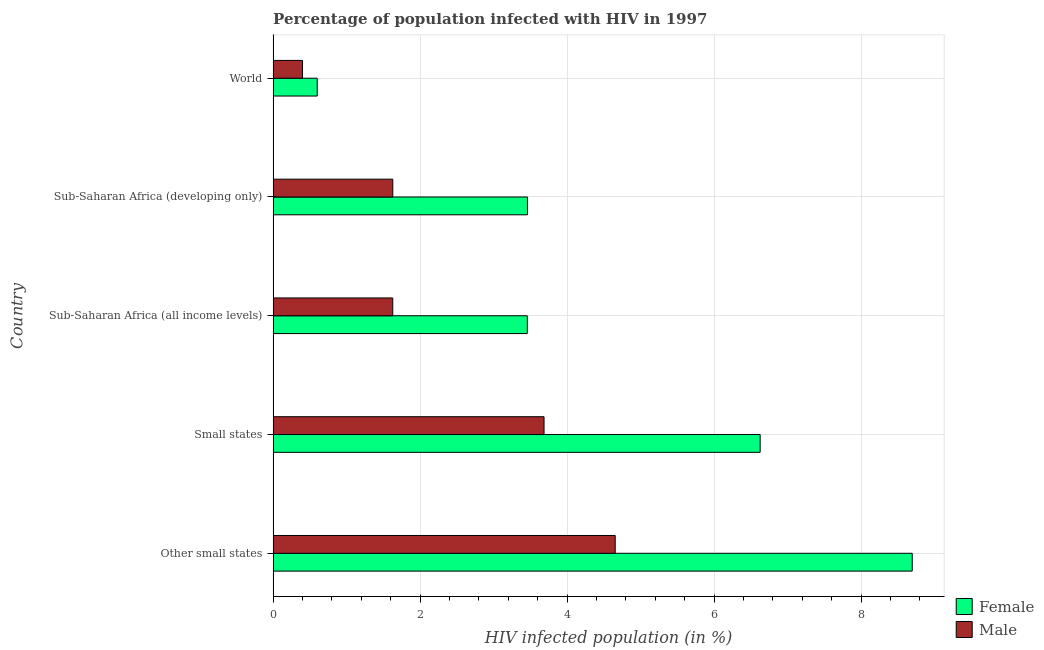How many groups of bars are there?
Your answer should be compact. 5. Are the number of bars on each tick of the Y-axis equal?
Your answer should be compact. Yes. How many bars are there on the 1st tick from the bottom?
Make the answer very short. 2. What is the label of the 5th group of bars from the top?
Offer a very short reply. Other small states. What is the percentage of females who are infected with hiv in Small states?
Offer a terse response. 6.63. Across all countries, what is the maximum percentage of males who are infected with hiv?
Your answer should be compact. 4.66. Across all countries, what is the minimum percentage of males who are infected with hiv?
Keep it short and to the point. 0.4. In which country was the percentage of females who are infected with hiv maximum?
Make the answer very short. Other small states. What is the total percentage of females who are infected with hiv in the graph?
Make the answer very short. 22.85. What is the difference between the percentage of males who are infected with hiv in Sub-Saharan Africa (all income levels) and that in Sub-Saharan Africa (developing only)?
Your answer should be compact. -0. What is the difference between the percentage of males who are infected with hiv in Sub-Saharan Africa (all income levels) and the percentage of females who are infected with hiv in Other small states?
Your answer should be compact. -7.07. What is the average percentage of females who are infected with hiv per country?
Make the answer very short. 4.57. What is the difference between the percentage of males who are infected with hiv and percentage of females who are infected with hiv in Small states?
Make the answer very short. -2.94. In how many countries, is the percentage of males who are infected with hiv greater than 6.8 %?
Your answer should be compact. 0. What is the ratio of the percentage of males who are infected with hiv in Other small states to that in Sub-Saharan Africa (developing only)?
Offer a terse response. 2.86. Is the percentage of females who are infected with hiv in Small states less than that in World?
Your response must be concise. No. What is the difference between the highest and the second highest percentage of females who are infected with hiv?
Provide a short and direct response. 2.07. What is the difference between the highest and the lowest percentage of females who are infected with hiv?
Your response must be concise. 8.1. What does the 2nd bar from the top in Other small states represents?
Give a very brief answer. Female. What does the 2nd bar from the bottom in Small states represents?
Your response must be concise. Male. How many bars are there?
Offer a very short reply. 10. Are all the bars in the graph horizontal?
Your answer should be compact. Yes. How many countries are there in the graph?
Your answer should be very brief. 5. Are the values on the major ticks of X-axis written in scientific E-notation?
Provide a succinct answer. No. Does the graph contain any zero values?
Offer a terse response. No. Does the graph contain grids?
Your response must be concise. Yes. Where does the legend appear in the graph?
Offer a terse response. Bottom right. How are the legend labels stacked?
Keep it short and to the point. Vertical. What is the title of the graph?
Your answer should be compact. Percentage of population infected with HIV in 1997. What is the label or title of the X-axis?
Your response must be concise. HIV infected population (in %). What is the label or title of the Y-axis?
Make the answer very short. Country. What is the HIV infected population (in %) in Female in Other small states?
Make the answer very short. 8.7. What is the HIV infected population (in %) of Male in Other small states?
Ensure brevity in your answer.  4.66. What is the HIV infected population (in %) in Female in Small states?
Make the answer very short. 6.63. What is the HIV infected population (in %) in Male in Small states?
Offer a very short reply. 3.69. What is the HIV infected population (in %) in Female in Sub-Saharan Africa (all income levels)?
Your answer should be very brief. 3.46. What is the HIV infected population (in %) in Male in Sub-Saharan Africa (all income levels)?
Provide a succinct answer. 1.63. What is the HIV infected population (in %) of Female in Sub-Saharan Africa (developing only)?
Ensure brevity in your answer.  3.46. What is the HIV infected population (in %) in Male in Sub-Saharan Africa (developing only)?
Give a very brief answer. 1.63. What is the HIV infected population (in %) in Female in World?
Your answer should be very brief. 0.6. Across all countries, what is the maximum HIV infected population (in %) in Female?
Offer a terse response. 8.7. Across all countries, what is the maximum HIV infected population (in %) in Male?
Ensure brevity in your answer.  4.66. Across all countries, what is the minimum HIV infected population (in %) in Female?
Your answer should be compact. 0.6. Across all countries, what is the minimum HIV infected population (in %) of Male?
Your answer should be very brief. 0.4. What is the total HIV infected population (in %) of Female in the graph?
Your answer should be very brief. 22.85. What is the total HIV infected population (in %) of Male in the graph?
Provide a short and direct response. 12. What is the difference between the HIV infected population (in %) in Female in Other small states and that in Small states?
Offer a very short reply. 2.07. What is the difference between the HIV infected population (in %) of Male in Other small states and that in Small states?
Give a very brief answer. 0.97. What is the difference between the HIV infected population (in %) in Female in Other small states and that in Sub-Saharan Africa (all income levels)?
Your answer should be very brief. 5.24. What is the difference between the HIV infected population (in %) in Male in Other small states and that in Sub-Saharan Africa (all income levels)?
Provide a succinct answer. 3.03. What is the difference between the HIV infected population (in %) in Female in Other small states and that in Sub-Saharan Africa (developing only)?
Offer a very short reply. 5.24. What is the difference between the HIV infected population (in %) of Male in Other small states and that in Sub-Saharan Africa (developing only)?
Ensure brevity in your answer.  3.03. What is the difference between the HIV infected population (in %) of Female in Other small states and that in World?
Provide a short and direct response. 8.1. What is the difference between the HIV infected population (in %) of Male in Other small states and that in World?
Ensure brevity in your answer.  4.26. What is the difference between the HIV infected population (in %) in Female in Small states and that in Sub-Saharan Africa (all income levels)?
Your answer should be compact. 3.17. What is the difference between the HIV infected population (in %) in Male in Small states and that in Sub-Saharan Africa (all income levels)?
Your response must be concise. 2.06. What is the difference between the HIV infected population (in %) of Female in Small states and that in Sub-Saharan Africa (developing only)?
Provide a succinct answer. 3.17. What is the difference between the HIV infected population (in %) of Male in Small states and that in Sub-Saharan Africa (developing only)?
Offer a terse response. 2.06. What is the difference between the HIV infected population (in %) in Female in Small states and that in World?
Keep it short and to the point. 6.03. What is the difference between the HIV infected population (in %) of Male in Small states and that in World?
Make the answer very short. 3.29. What is the difference between the HIV infected population (in %) in Female in Sub-Saharan Africa (all income levels) and that in Sub-Saharan Africa (developing only)?
Offer a very short reply. -0. What is the difference between the HIV infected population (in %) of Male in Sub-Saharan Africa (all income levels) and that in Sub-Saharan Africa (developing only)?
Offer a terse response. -0. What is the difference between the HIV infected population (in %) in Female in Sub-Saharan Africa (all income levels) and that in World?
Your answer should be very brief. 2.86. What is the difference between the HIV infected population (in %) in Male in Sub-Saharan Africa (all income levels) and that in World?
Provide a succinct answer. 1.23. What is the difference between the HIV infected population (in %) in Female in Sub-Saharan Africa (developing only) and that in World?
Offer a terse response. 2.86. What is the difference between the HIV infected population (in %) of Male in Sub-Saharan Africa (developing only) and that in World?
Your response must be concise. 1.23. What is the difference between the HIV infected population (in %) of Female in Other small states and the HIV infected population (in %) of Male in Small states?
Your answer should be compact. 5.01. What is the difference between the HIV infected population (in %) of Female in Other small states and the HIV infected population (in %) of Male in Sub-Saharan Africa (all income levels)?
Give a very brief answer. 7.07. What is the difference between the HIV infected population (in %) of Female in Other small states and the HIV infected population (in %) of Male in Sub-Saharan Africa (developing only)?
Offer a terse response. 7.07. What is the difference between the HIV infected population (in %) in Female in Other small states and the HIV infected population (in %) in Male in World?
Your response must be concise. 8.3. What is the difference between the HIV infected population (in %) in Female in Small states and the HIV infected population (in %) in Male in Sub-Saharan Africa (all income levels)?
Offer a terse response. 5. What is the difference between the HIV infected population (in %) in Female in Small states and the HIV infected population (in %) in Male in Sub-Saharan Africa (developing only)?
Provide a succinct answer. 5. What is the difference between the HIV infected population (in %) in Female in Small states and the HIV infected population (in %) in Male in World?
Ensure brevity in your answer.  6.23. What is the difference between the HIV infected population (in %) in Female in Sub-Saharan Africa (all income levels) and the HIV infected population (in %) in Male in Sub-Saharan Africa (developing only)?
Provide a succinct answer. 1.83. What is the difference between the HIV infected population (in %) in Female in Sub-Saharan Africa (all income levels) and the HIV infected population (in %) in Male in World?
Give a very brief answer. 3.06. What is the difference between the HIV infected population (in %) in Female in Sub-Saharan Africa (developing only) and the HIV infected population (in %) in Male in World?
Your response must be concise. 3.06. What is the average HIV infected population (in %) of Female per country?
Your answer should be very brief. 4.57. What is the average HIV infected population (in %) of Male per country?
Your response must be concise. 2.4. What is the difference between the HIV infected population (in %) in Female and HIV infected population (in %) in Male in Other small states?
Offer a terse response. 4.04. What is the difference between the HIV infected population (in %) in Female and HIV infected population (in %) in Male in Small states?
Give a very brief answer. 2.94. What is the difference between the HIV infected population (in %) of Female and HIV infected population (in %) of Male in Sub-Saharan Africa (all income levels)?
Give a very brief answer. 1.83. What is the difference between the HIV infected population (in %) of Female and HIV infected population (in %) of Male in Sub-Saharan Africa (developing only)?
Offer a very short reply. 1.83. What is the difference between the HIV infected population (in %) of Female and HIV infected population (in %) of Male in World?
Give a very brief answer. 0.2. What is the ratio of the HIV infected population (in %) in Female in Other small states to that in Small states?
Your response must be concise. 1.31. What is the ratio of the HIV infected population (in %) of Male in Other small states to that in Small states?
Provide a short and direct response. 1.26. What is the ratio of the HIV infected population (in %) of Female in Other small states to that in Sub-Saharan Africa (all income levels)?
Offer a terse response. 2.51. What is the ratio of the HIV infected population (in %) in Male in Other small states to that in Sub-Saharan Africa (all income levels)?
Give a very brief answer. 2.86. What is the ratio of the HIV infected population (in %) in Female in Other small states to that in Sub-Saharan Africa (developing only)?
Provide a short and direct response. 2.51. What is the ratio of the HIV infected population (in %) of Male in Other small states to that in Sub-Saharan Africa (developing only)?
Your answer should be compact. 2.86. What is the ratio of the HIV infected population (in %) of Female in Other small states to that in World?
Provide a succinct answer. 14.5. What is the ratio of the HIV infected population (in %) in Male in Other small states to that in World?
Give a very brief answer. 11.64. What is the ratio of the HIV infected population (in %) of Female in Small states to that in Sub-Saharan Africa (all income levels)?
Your answer should be compact. 1.92. What is the ratio of the HIV infected population (in %) of Male in Small states to that in Sub-Saharan Africa (all income levels)?
Provide a succinct answer. 2.26. What is the ratio of the HIV infected population (in %) of Female in Small states to that in Sub-Saharan Africa (developing only)?
Provide a short and direct response. 1.92. What is the ratio of the HIV infected population (in %) of Male in Small states to that in Sub-Saharan Africa (developing only)?
Give a very brief answer. 2.26. What is the ratio of the HIV infected population (in %) in Female in Small states to that in World?
Offer a terse response. 11.05. What is the ratio of the HIV infected population (in %) of Male in Small states to that in World?
Keep it short and to the point. 9.22. What is the ratio of the HIV infected population (in %) of Female in Sub-Saharan Africa (all income levels) to that in World?
Give a very brief answer. 5.77. What is the ratio of the HIV infected population (in %) in Male in Sub-Saharan Africa (all income levels) to that in World?
Your answer should be compact. 4.07. What is the ratio of the HIV infected population (in %) of Female in Sub-Saharan Africa (developing only) to that in World?
Provide a succinct answer. 5.77. What is the ratio of the HIV infected population (in %) in Male in Sub-Saharan Africa (developing only) to that in World?
Make the answer very short. 4.07. What is the difference between the highest and the second highest HIV infected population (in %) of Female?
Provide a succinct answer. 2.07. What is the difference between the highest and the second highest HIV infected population (in %) of Male?
Your response must be concise. 0.97. What is the difference between the highest and the lowest HIV infected population (in %) in Female?
Offer a terse response. 8.1. What is the difference between the highest and the lowest HIV infected population (in %) of Male?
Your answer should be compact. 4.26. 